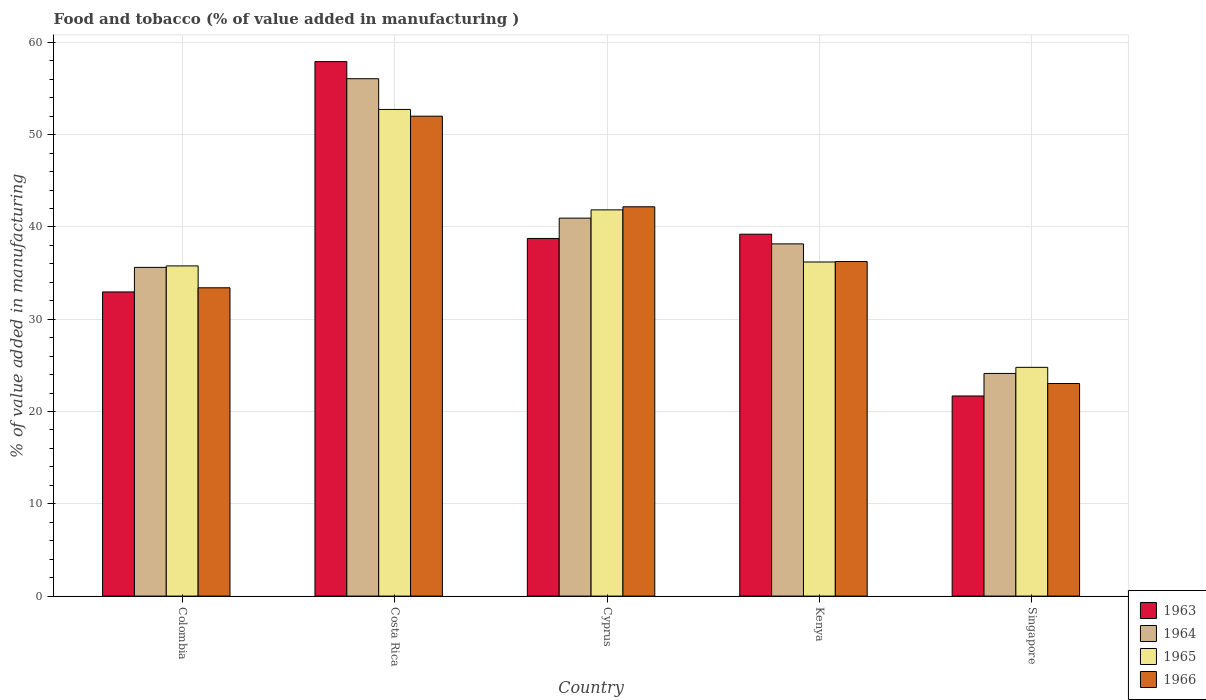How many groups of bars are there?
Offer a terse response. 5. Are the number of bars per tick equal to the number of legend labels?
Make the answer very short. Yes. How many bars are there on the 3rd tick from the left?
Give a very brief answer. 4. How many bars are there on the 1st tick from the right?
Provide a short and direct response. 4. What is the label of the 3rd group of bars from the left?
Keep it short and to the point. Cyprus. In how many cases, is the number of bars for a given country not equal to the number of legend labels?
Ensure brevity in your answer.  0. What is the value added in manufacturing food and tobacco in 1963 in Costa Rica?
Your answer should be very brief. 57.92. Across all countries, what is the maximum value added in manufacturing food and tobacco in 1965?
Ensure brevity in your answer.  52.73. Across all countries, what is the minimum value added in manufacturing food and tobacco in 1965?
Offer a terse response. 24.79. In which country was the value added in manufacturing food and tobacco in 1964 minimum?
Make the answer very short. Singapore. What is the total value added in manufacturing food and tobacco in 1965 in the graph?
Provide a short and direct response. 191.36. What is the difference between the value added in manufacturing food and tobacco in 1963 in Colombia and that in Cyprus?
Offer a very short reply. -5.79. What is the difference between the value added in manufacturing food and tobacco in 1966 in Singapore and the value added in manufacturing food and tobacco in 1963 in Costa Rica?
Your answer should be compact. -34.88. What is the average value added in manufacturing food and tobacco in 1965 per country?
Provide a short and direct response. 38.27. What is the difference between the value added in manufacturing food and tobacco of/in 1965 and value added in manufacturing food and tobacco of/in 1963 in Singapore?
Give a very brief answer. 3.1. In how many countries, is the value added in manufacturing food and tobacco in 1964 greater than 46 %?
Offer a very short reply. 1. What is the ratio of the value added in manufacturing food and tobacco in 1965 in Costa Rica to that in Singapore?
Give a very brief answer. 2.13. Is the value added in manufacturing food and tobacco in 1966 in Costa Rica less than that in Cyprus?
Your answer should be compact. No. What is the difference between the highest and the second highest value added in manufacturing food and tobacco in 1964?
Ensure brevity in your answer.  15.11. What is the difference between the highest and the lowest value added in manufacturing food and tobacco in 1964?
Offer a very short reply. 31.94. Is it the case that in every country, the sum of the value added in manufacturing food and tobacco in 1963 and value added in manufacturing food and tobacco in 1964 is greater than the sum of value added in manufacturing food and tobacco in 1966 and value added in manufacturing food and tobacco in 1965?
Your response must be concise. No. What does the 4th bar from the left in Cyprus represents?
Your response must be concise. 1966. What does the 2nd bar from the right in Colombia represents?
Offer a very short reply. 1965. How many bars are there?
Provide a succinct answer. 20. What is the difference between two consecutive major ticks on the Y-axis?
Keep it short and to the point. 10. How are the legend labels stacked?
Ensure brevity in your answer.  Vertical. What is the title of the graph?
Provide a succinct answer. Food and tobacco (% of value added in manufacturing ). What is the label or title of the Y-axis?
Your response must be concise. % of value added in manufacturing. What is the % of value added in manufacturing in 1963 in Colombia?
Offer a very short reply. 32.96. What is the % of value added in manufacturing of 1964 in Colombia?
Ensure brevity in your answer.  35.62. What is the % of value added in manufacturing of 1965 in Colombia?
Your response must be concise. 35.78. What is the % of value added in manufacturing of 1966 in Colombia?
Offer a very short reply. 33.41. What is the % of value added in manufacturing in 1963 in Costa Rica?
Provide a succinct answer. 57.92. What is the % of value added in manufacturing of 1964 in Costa Rica?
Your answer should be very brief. 56.07. What is the % of value added in manufacturing in 1965 in Costa Rica?
Your answer should be compact. 52.73. What is the % of value added in manufacturing of 1966 in Costa Rica?
Provide a succinct answer. 52. What is the % of value added in manufacturing in 1963 in Cyprus?
Your answer should be very brief. 38.75. What is the % of value added in manufacturing in 1964 in Cyprus?
Ensure brevity in your answer.  40.96. What is the % of value added in manufacturing of 1965 in Cyprus?
Provide a short and direct response. 41.85. What is the % of value added in manufacturing in 1966 in Cyprus?
Provide a short and direct response. 42.19. What is the % of value added in manufacturing in 1963 in Kenya?
Ensure brevity in your answer.  39.22. What is the % of value added in manufacturing in 1964 in Kenya?
Make the answer very short. 38.17. What is the % of value added in manufacturing of 1965 in Kenya?
Ensure brevity in your answer.  36.2. What is the % of value added in manufacturing of 1966 in Kenya?
Offer a terse response. 36.25. What is the % of value added in manufacturing in 1963 in Singapore?
Keep it short and to the point. 21.69. What is the % of value added in manufacturing of 1964 in Singapore?
Your response must be concise. 24.13. What is the % of value added in manufacturing in 1965 in Singapore?
Your answer should be compact. 24.79. What is the % of value added in manufacturing of 1966 in Singapore?
Your answer should be very brief. 23.04. Across all countries, what is the maximum % of value added in manufacturing of 1963?
Your answer should be compact. 57.92. Across all countries, what is the maximum % of value added in manufacturing of 1964?
Offer a terse response. 56.07. Across all countries, what is the maximum % of value added in manufacturing of 1965?
Offer a very short reply. 52.73. Across all countries, what is the maximum % of value added in manufacturing in 1966?
Keep it short and to the point. 52. Across all countries, what is the minimum % of value added in manufacturing of 1963?
Your response must be concise. 21.69. Across all countries, what is the minimum % of value added in manufacturing in 1964?
Offer a very short reply. 24.13. Across all countries, what is the minimum % of value added in manufacturing of 1965?
Provide a short and direct response. 24.79. Across all countries, what is the minimum % of value added in manufacturing in 1966?
Your response must be concise. 23.04. What is the total % of value added in manufacturing of 1963 in the graph?
Your answer should be compact. 190.54. What is the total % of value added in manufacturing of 1964 in the graph?
Your answer should be very brief. 194.94. What is the total % of value added in manufacturing of 1965 in the graph?
Offer a terse response. 191.36. What is the total % of value added in manufacturing of 1966 in the graph?
Give a very brief answer. 186.89. What is the difference between the % of value added in manufacturing of 1963 in Colombia and that in Costa Rica?
Your answer should be compact. -24.96. What is the difference between the % of value added in manufacturing in 1964 in Colombia and that in Costa Rica?
Ensure brevity in your answer.  -20.45. What is the difference between the % of value added in manufacturing in 1965 in Colombia and that in Costa Rica?
Make the answer very short. -16.95. What is the difference between the % of value added in manufacturing in 1966 in Colombia and that in Costa Rica?
Make the answer very short. -18.59. What is the difference between the % of value added in manufacturing in 1963 in Colombia and that in Cyprus?
Your answer should be compact. -5.79. What is the difference between the % of value added in manufacturing in 1964 in Colombia and that in Cyprus?
Your answer should be very brief. -5.34. What is the difference between the % of value added in manufacturing of 1965 in Colombia and that in Cyprus?
Provide a short and direct response. -6.07. What is the difference between the % of value added in manufacturing of 1966 in Colombia and that in Cyprus?
Your response must be concise. -8.78. What is the difference between the % of value added in manufacturing of 1963 in Colombia and that in Kenya?
Make the answer very short. -6.26. What is the difference between the % of value added in manufacturing of 1964 in Colombia and that in Kenya?
Your answer should be very brief. -2.55. What is the difference between the % of value added in manufacturing of 1965 in Colombia and that in Kenya?
Your answer should be very brief. -0.42. What is the difference between the % of value added in manufacturing of 1966 in Colombia and that in Kenya?
Your answer should be very brief. -2.84. What is the difference between the % of value added in manufacturing of 1963 in Colombia and that in Singapore?
Your response must be concise. 11.27. What is the difference between the % of value added in manufacturing in 1964 in Colombia and that in Singapore?
Provide a succinct answer. 11.49. What is the difference between the % of value added in manufacturing in 1965 in Colombia and that in Singapore?
Ensure brevity in your answer.  10.99. What is the difference between the % of value added in manufacturing of 1966 in Colombia and that in Singapore?
Offer a very short reply. 10.37. What is the difference between the % of value added in manufacturing in 1963 in Costa Rica and that in Cyprus?
Keep it short and to the point. 19.17. What is the difference between the % of value added in manufacturing in 1964 in Costa Rica and that in Cyprus?
Your answer should be very brief. 15.11. What is the difference between the % of value added in manufacturing of 1965 in Costa Rica and that in Cyprus?
Provide a succinct answer. 10.88. What is the difference between the % of value added in manufacturing in 1966 in Costa Rica and that in Cyprus?
Your answer should be very brief. 9.82. What is the difference between the % of value added in manufacturing in 1963 in Costa Rica and that in Kenya?
Offer a terse response. 18.7. What is the difference between the % of value added in manufacturing in 1964 in Costa Rica and that in Kenya?
Ensure brevity in your answer.  17.9. What is the difference between the % of value added in manufacturing of 1965 in Costa Rica and that in Kenya?
Offer a very short reply. 16.53. What is the difference between the % of value added in manufacturing of 1966 in Costa Rica and that in Kenya?
Offer a terse response. 15.75. What is the difference between the % of value added in manufacturing in 1963 in Costa Rica and that in Singapore?
Provide a short and direct response. 36.23. What is the difference between the % of value added in manufacturing of 1964 in Costa Rica and that in Singapore?
Your answer should be very brief. 31.94. What is the difference between the % of value added in manufacturing in 1965 in Costa Rica and that in Singapore?
Your answer should be very brief. 27.94. What is the difference between the % of value added in manufacturing of 1966 in Costa Rica and that in Singapore?
Your answer should be very brief. 28.97. What is the difference between the % of value added in manufacturing in 1963 in Cyprus and that in Kenya?
Provide a succinct answer. -0.46. What is the difference between the % of value added in manufacturing in 1964 in Cyprus and that in Kenya?
Provide a short and direct response. 2.79. What is the difference between the % of value added in manufacturing of 1965 in Cyprus and that in Kenya?
Offer a very short reply. 5.65. What is the difference between the % of value added in manufacturing in 1966 in Cyprus and that in Kenya?
Offer a very short reply. 5.93. What is the difference between the % of value added in manufacturing in 1963 in Cyprus and that in Singapore?
Your answer should be compact. 17.07. What is the difference between the % of value added in manufacturing in 1964 in Cyprus and that in Singapore?
Keep it short and to the point. 16.83. What is the difference between the % of value added in manufacturing in 1965 in Cyprus and that in Singapore?
Your answer should be very brief. 17.06. What is the difference between the % of value added in manufacturing in 1966 in Cyprus and that in Singapore?
Offer a terse response. 19.15. What is the difference between the % of value added in manufacturing in 1963 in Kenya and that in Singapore?
Offer a terse response. 17.53. What is the difference between the % of value added in manufacturing of 1964 in Kenya and that in Singapore?
Make the answer very short. 14.04. What is the difference between the % of value added in manufacturing of 1965 in Kenya and that in Singapore?
Provide a short and direct response. 11.41. What is the difference between the % of value added in manufacturing of 1966 in Kenya and that in Singapore?
Give a very brief answer. 13.22. What is the difference between the % of value added in manufacturing in 1963 in Colombia and the % of value added in manufacturing in 1964 in Costa Rica?
Provide a short and direct response. -23.11. What is the difference between the % of value added in manufacturing of 1963 in Colombia and the % of value added in manufacturing of 1965 in Costa Rica?
Your answer should be very brief. -19.77. What is the difference between the % of value added in manufacturing of 1963 in Colombia and the % of value added in manufacturing of 1966 in Costa Rica?
Make the answer very short. -19.04. What is the difference between the % of value added in manufacturing of 1964 in Colombia and the % of value added in manufacturing of 1965 in Costa Rica?
Offer a very short reply. -17.11. What is the difference between the % of value added in manufacturing of 1964 in Colombia and the % of value added in manufacturing of 1966 in Costa Rica?
Provide a succinct answer. -16.38. What is the difference between the % of value added in manufacturing in 1965 in Colombia and the % of value added in manufacturing in 1966 in Costa Rica?
Ensure brevity in your answer.  -16.22. What is the difference between the % of value added in manufacturing in 1963 in Colombia and the % of value added in manufacturing in 1964 in Cyprus?
Ensure brevity in your answer.  -8. What is the difference between the % of value added in manufacturing of 1963 in Colombia and the % of value added in manufacturing of 1965 in Cyprus?
Your response must be concise. -8.89. What is the difference between the % of value added in manufacturing of 1963 in Colombia and the % of value added in manufacturing of 1966 in Cyprus?
Make the answer very short. -9.23. What is the difference between the % of value added in manufacturing of 1964 in Colombia and the % of value added in manufacturing of 1965 in Cyprus?
Offer a very short reply. -6.23. What is the difference between the % of value added in manufacturing in 1964 in Colombia and the % of value added in manufacturing in 1966 in Cyprus?
Keep it short and to the point. -6.57. What is the difference between the % of value added in manufacturing of 1965 in Colombia and the % of value added in manufacturing of 1966 in Cyprus?
Your answer should be very brief. -6.41. What is the difference between the % of value added in manufacturing of 1963 in Colombia and the % of value added in manufacturing of 1964 in Kenya?
Your answer should be very brief. -5.21. What is the difference between the % of value added in manufacturing of 1963 in Colombia and the % of value added in manufacturing of 1965 in Kenya?
Provide a short and direct response. -3.24. What is the difference between the % of value added in manufacturing of 1963 in Colombia and the % of value added in manufacturing of 1966 in Kenya?
Provide a short and direct response. -3.29. What is the difference between the % of value added in manufacturing in 1964 in Colombia and the % of value added in manufacturing in 1965 in Kenya?
Keep it short and to the point. -0.58. What is the difference between the % of value added in manufacturing in 1964 in Colombia and the % of value added in manufacturing in 1966 in Kenya?
Make the answer very short. -0.63. What is the difference between the % of value added in manufacturing in 1965 in Colombia and the % of value added in manufacturing in 1966 in Kenya?
Give a very brief answer. -0.47. What is the difference between the % of value added in manufacturing in 1963 in Colombia and the % of value added in manufacturing in 1964 in Singapore?
Your answer should be very brief. 8.83. What is the difference between the % of value added in manufacturing of 1963 in Colombia and the % of value added in manufacturing of 1965 in Singapore?
Provide a short and direct response. 8.17. What is the difference between the % of value added in manufacturing in 1963 in Colombia and the % of value added in manufacturing in 1966 in Singapore?
Give a very brief answer. 9.92. What is the difference between the % of value added in manufacturing of 1964 in Colombia and the % of value added in manufacturing of 1965 in Singapore?
Provide a short and direct response. 10.83. What is the difference between the % of value added in manufacturing in 1964 in Colombia and the % of value added in manufacturing in 1966 in Singapore?
Make the answer very short. 12.58. What is the difference between the % of value added in manufacturing of 1965 in Colombia and the % of value added in manufacturing of 1966 in Singapore?
Your answer should be compact. 12.74. What is the difference between the % of value added in manufacturing of 1963 in Costa Rica and the % of value added in manufacturing of 1964 in Cyprus?
Ensure brevity in your answer.  16.96. What is the difference between the % of value added in manufacturing in 1963 in Costa Rica and the % of value added in manufacturing in 1965 in Cyprus?
Offer a very short reply. 16.07. What is the difference between the % of value added in manufacturing in 1963 in Costa Rica and the % of value added in manufacturing in 1966 in Cyprus?
Your response must be concise. 15.73. What is the difference between the % of value added in manufacturing in 1964 in Costa Rica and the % of value added in manufacturing in 1965 in Cyprus?
Offer a very short reply. 14.21. What is the difference between the % of value added in manufacturing of 1964 in Costa Rica and the % of value added in manufacturing of 1966 in Cyprus?
Make the answer very short. 13.88. What is the difference between the % of value added in manufacturing in 1965 in Costa Rica and the % of value added in manufacturing in 1966 in Cyprus?
Make the answer very short. 10.55. What is the difference between the % of value added in manufacturing in 1963 in Costa Rica and the % of value added in manufacturing in 1964 in Kenya?
Give a very brief answer. 19.75. What is the difference between the % of value added in manufacturing of 1963 in Costa Rica and the % of value added in manufacturing of 1965 in Kenya?
Your response must be concise. 21.72. What is the difference between the % of value added in manufacturing in 1963 in Costa Rica and the % of value added in manufacturing in 1966 in Kenya?
Your response must be concise. 21.67. What is the difference between the % of value added in manufacturing in 1964 in Costa Rica and the % of value added in manufacturing in 1965 in Kenya?
Make the answer very short. 19.86. What is the difference between the % of value added in manufacturing in 1964 in Costa Rica and the % of value added in manufacturing in 1966 in Kenya?
Provide a short and direct response. 19.81. What is the difference between the % of value added in manufacturing of 1965 in Costa Rica and the % of value added in manufacturing of 1966 in Kenya?
Keep it short and to the point. 16.48. What is the difference between the % of value added in manufacturing in 1963 in Costa Rica and the % of value added in manufacturing in 1964 in Singapore?
Provide a short and direct response. 33.79. What is the difference between the % of value added in manufacturing in 1963 in Costa Rica and the % of value added in manufacturing in 1965 in Singapore?
Offer a very short reply. 33.13. What is the difference between the % of value added in manufacturing of 1963 in Costa Rica and the % of value added in manufacturing of 1966 in Singapore?
Your answer should be very brief. 34.88. What is the difference between the % of value added in manufacturing of 1964 in Costa Rica and the % of value added in manufacturing of 1965 in Singapore?
Your answer should be very brief. 31.28. What is the difference between the % of value added in manufacturing of 1964 in Costa Rica and the % of value added in manufacturing of 1966 in Singapore?
Make the answer very short. 33.03. What is the difference between the % of value added in manufacturing in 1965 in Costa Rica and the % of value added in manufacturing in 1966 in Singapore?
Your answer should be compact. 29.7. What is the difference between the % of value added in manufacturing of 1963 in Cyprus and the % of value added in manufacturing of 1964 in Kenya?
Provide a short and direct response. 0.59. What is the difference between the % of value added in manufacturing in 1963 in Cyprus and the % of value added in manufacturing in 1965 in Kenya?
Ensure brevity in your answer.  2.55. What is the difference between the % of value added in manufacturing in 1963 in Cyprus and the % of value added in manufacturing in 1966 in Kenya?
Keep it short and to the point. 2.5. What is the difference between the % of value added in manufacturing of 1964 in Cyprus and the % of value added in manufacturing of 1965 in Kenya?
Your response must be concise. 4.75. What is the difference between the % of value added in manufacturing of 1964 in Cyprus and the % of value added in manufacturing of 1966 in Kenya?
Make the answer very short. 4.7. What is the difference between the % of value added in manufacturing of 1965 in Cyprus and the % of value added in manufacturing of 1966 in Kenya?
Your response must be concise. 5.6. What is the difference between the % of value added in manufacturing of 1963 in Cyprus and the % of value added in manufacturing of 1964 in Singapore?
Your response must be concise. 14.63. What is the difference between the % of value added in manufacturing in 1963 in Cyprus and the % of value added in manufacturing in 1965 in Singapore?
Your response must be concise. 13.96. What is the difference between the % of value added in manufacturing in 1963 in Cyprus and the % of value added in manufacturing in 1966 in Singapore?
Your response must be concise. 15.72. What is the difference between the % of value added in manufacturing of 1964 in Cyprus and the % of value added in manufacturing of 1965 in Singapore?
Keep it short and to the point. 16.17. What is the difference between the % of value added in manufacturing in 1964 in Cyprus and the % of value added in manufacturing in 1966 in Singapore?
Provide a short and direct response. 17.92. What is the difference between the % of value added in manufacturing of 1965 in Cyprus and the % of value added in manufacturing of 1966 in Singapore?
Your answer should be very brief. 18.82. What is the difference between the % of value added in manufacturing in 1963 in Kenya and the % of value added in manufacturing in 1964 in Singapore?
Your answer should be very brief. 15.09. What is the difference between the % of value added in manufacturing in 1963 in Kenya and the % of value added in manufacturing in 1965 in Singapore?
Ensure brevity in your answer.  14.43. What is the difference between the % of value added in manufacturing in 1963 in Kenya and the % of value added in manufacturing in 1966 in Singapore?
Give a very brief answer. 16.18. What is the difference between the % of value added in manufacturing in 1964 in Kenya and the % of value added in manufacturing in 1965 in Singapore?
Provide a succinct answer. 13.38. What is the difference between the % of value added in manufacturing of 1964 in Kenya and the % of value added in manufacturing of 1966 in Singapore?
Your answer should be compact. 15.13. What is the difference between the % of value added in manufacturing in 1965 in Kenya and the % of value added in manufacturing in 1966 in Singapore?
Provide a succinct answer. 13.17. What is the average % of value added in manufacturing in 1963 per country?
Your response must be concise. 38.11. What is the average % of value added in manufacturing in 1964 per country?
Your response must be concise. 38.99. What is the average % of value added in manufacturing in 1965 per country?
Provide a short and direct response. 38.27. What is the average % of value added in manufacturing in 1966 per country?
Ensure brevity in your answer.  37.38. What is the difference between the % of value added in manufacturing in 1963 and % of value added in manufacturing in 1964 in Colombia?
Offer a very short reply. -2.66. What is the difference between the % of value added in manufacturing in 1963 and % of value added in manufacturing in 1965 in Colombia?
Your answer should be compact. -2.82. What is the difference between the % of value added in manufacturing in 1963 and % of value added in manufacturing in 1966 in Colombia?
Your answer should be compact. -0.45. What is the difference between the % of value added in manufacturing of 1964 and % of value added in manufacturing of 1965 in Colombia?
Ensure brevity in your answer.  -0.16. What is the difference between the % of value added in manufacturing of 1964 and % of value added in manufacturing of 1966 in Colombia?
Provide a succinct answer. 2.21. What is the difference between the % of value added in manufacturing in 1965 and % of value added in manufacturing in 1966 in Colombia?
Offer a terse response. 2.37. What is the difference between the % of value added in manufacturing of 1963 and % of value added in manufacturing of 1964 in Costa Rica?
Provide a succinct answer. 1.85. What is the difference between the % of value added in manufacturing of 1963 and % of value added in manufacturing of 1965 in Costa Rica?
Provide a short and direct response. 5.19. What is the difference between the % of value added in manufacturing of 1963 and % of value added in manufacturing of 1966 in Costa Rica?
Offer a terse response. 5.92. What is the difference between the % of value added in manufacturing of 1964 and % of value added in manufacturing of 1965 in Costa Rica?
Your response must be concise. 3.33. What is the difference between the % of value added in manufacturing in 1964 and % of value added in manufacturing in 1966 in Costa Rica?
Keep it short and to the point. 4.06. What is the difference between the % of value added in manufacturing of 1965 and % of value added in manufacturing of 1966 in Costa Rica?
Provide a short and direct response. 0.73. What is the difference between the % of value added in manufacturing in 1963 and % of value added in manufacturing in 1964 in Cyprus?
Offer a very short reply. -2.2. What is the difference between the % of value added in manufacturing in 1963 and % of value added in manufacturing in 1965 in Cyprus?
Your response must be concise. -3.1. What is the difference between the % of value added in manufacturing of 1963 and % of value added in manufacturing of 1966 in Cyprus?
Your answer should be very brief. -3.43. What is the difference between the % of value added in manufacturing in 1964 and % of value added in manufacturing in 1965 in Cyprus?
Ensure brevity in your answer.  -0.9. What is the difference between the % of value added in manufacturing in 1964 and % of value added in manufacturing in 1966 in Cyprus?
Provide a short and direct response. -1.23. What is the difference between the % of value added in manufacturing in 1963 and % of value added in manufacturing in 1964 in Kenya?
Ensure brevity in your answer.  1.05. What is the difference between the % of value added in manufacturing of 1963 and % of value added in manufacturing of 1965 in Kenya?
Your answer should be very brief. 3.01. What is the difference between the % of value added in manufacturing of 1963 and % of value added in manufacturing of 1966 in Kenya?
Provide a succinct answer. 2.96. What is the difference between the % of value added in manufacturing of 1964 and % of value added in manufacturing of 1965 in Kenya?
Give a very brief answer. 1.96. What is the difference between the % of value added in manufacturing of 1964 and % of value added in manufacturing of 1966 in Kenya?
Offer a very short reply. 1.91. What is the difference between the % of value added in manufacturing of 1963 and % of value added in manufacturing of 1964 in Singapore?
Your answer should be very brief. -2.44. What is the difference between the % of value added in manufacturing of 1963 and % of value added in manufacturing of 1965 in Singapore?
Provide a short and direct response. -3.1. What is the difference between the % of value added in manufacturing in 1963 and % of value added in manufacturing in 1966 in Singapore?
Offer a terse response. -1.35. What is the difference between the % of value added in manufacturing in 1964 and % of value added in manufacturing in 1965 in Singapore?
Keep it short and to the point. -0.66. What is the difference between the % of value added in manufacturing of 1964 and % of value added in manufacturing of 1966 in Singapore?
Give a very brief answer. 1.09. What is the difference between the % of value added in manufacturing in 1965 and % of value added in manufacturing in 1966 in Singapore?
Keep it short and to the point. 1.75. What is the ratio of the % of value added in manufacturing of 1963 in Colombia to that in Costa Rica?
Offer a terse response. 0.57. What is the ratio of the % of value added in manufacturing of 1964 in Colombia to that in Costa Rica?
Offer a terse response. 0.64. What is the ratio of the % of value added in manufacturing in 1965 in Colombia to that in Costa Rica?
Give a very brief answer. 0.68. What is the ratio of the % of value added in manufacturing in 1966 in Colombia to that in Costa Rica?
Provide a succinct answer. 0.64. What is the ratio of the % of value added in manufacturing in 1963 in Colombia to that in Cyprus?
Give a very brief answer. 0.85. What is the ratio of the % of value added in manufacturing in 1964 in Colombia to that in Cyprus?
Provide a succinct answer. 0.87. What is the ratio of the % of value added in manufacturing of 1965 in Colombia to that in Cyprus?
Keep it short and to the point. 0.85. What is the ratio of the % of value added in manufacturing in 1966 in Colombia to that in Cyprus?
Keep it short and to the point. 0.79. What is the ratio of the % of value added in manufacturing in 1963 in Colombia to that in Kenya?
Provide a succinct answer. 0.84. What is the ratio of the % of value added in manufacturing of 1964 in Colombia to that in Kenya?
Give a very brief answer. 0.93. What is the ratio of the % of value added in manufacturing in 1965 in Colombia to that in Kenya?
Offer a very short reply. 0.99. What is the ratio of the % of value added in manufacturing of 1966 in Colombia to that in Kenya?
Your response must be concise. 0.92. What is the ratio of the % of value added in manufacturing in 1963 in Colombia to that in Singapore?
Offer a very short reply. 1.52. What is the ratio of the % of value added in manufacturing in 1964 in Colombia to that in Singapore?
Your answer should be compact. 1.48. What is the ratio of the % of value added in manufacturing of 1965 in Colombia to that in Singapore?
Give a very brief answer. 1.44. What is the ratio of the % of value added in manufacturing of 1966 in Colombia to that in Singapore?
Your answer should be compact. 1.45. What is the ratio of the % of value added in manufacturing in 1963 in Costa Rica to that in Cyprus?
Give a very brief answer. 1.49. What is the ratio of the % of value added in manufacturing of 1964 in Costa Rica to that in Cyprus?
Provide a succinct answer. 1.37. What is the ratio of the % of value added in manufacturing of 1965 in Costa Rica to that in Cyprus?
Give a very brief answer. 1.26. What is the ratio of the % of value added in manufacturing of 1966 in Costa Rica to that in Cyprus?
Your answer should be very brief. 1.23. What is the ratio of the % of value added in manufacturing in 1963 in Costa Rica to that in Kenya?
Give a very brief answer. 1.48. What is the ratio of the % of value added in manufacturing of 1964 in Costa Rica to that in Kenya?
Offer a very short reply. 1.47. What is the ratio of the % of value added in manufacturing in 1965 in Costa Rica to that in Kenya?
Offer a terse response. 1.46. What is the ratio of the % of value added in manufacturing of 1966 in Costa Rica to that in Kenya?
Your response must be concise. 1.43. What is the ratio of the % of value added in manufacturing in 1963 in Costa Rica to that in Singapore?
Your answer should be very brief. 2.67. What is the ratio of the % of value added in manufacturing in 1964 in Costa Rica to that in Singapore?
Ensure brevity in your answer.  2.32. What is the ratio of the % of value added in manufacturing in 1965 in Costa Rica to that in Singapore?
Offer a terse response. 2.13. What is the ratio of the % of value added in manufacturing of 1966 in Costa Rica to that in Singapore?
Your response must be concise. 2.26. What is the ratio of the % of value added in manufacturing in 1963 in Cyprus to that in Kenya?
Offer a terse response. 0.99. What is the ratio of the % of value added in manufacturing of 1964 in Cyprus to that in Kenya?
Offer a very short reply. 1.07. What is the ratio of the % of value added in manufacturing of 1965 in Cyprus to that in Kenya?
Keep it short and to the point. 1.16. What is the ratio of the % of value added in manufacturing in 1966 in Cyprus to that in Kenya?
Keep it short and to the point. 1.16. What is the ratio of the % of value added in manufacturing of 1963 in Cyprus to that in Singapore?
Give a very brief answer. 1.79. What is the ratio of the % of value added in manufacturing of 1964 in Cyprus to that in Singapore?
Make the answer very short. 1.7. What is the ratio of the % of value added in manufacturing in 1965 in Cyprus to that in Singapore?
Keep it short and to the point. 1.69. What is the ratio of the % of value added in manufacturing in 1966 in Cyprus to that in Singapore?
Provide a succinct answer. 1.83. What is the ratio of the % of value added in manufacturing in 1963 in Kenya to that in Singapore?
Ensure brevity in your answer.  1.81. What is the ratio of the % of value added in manufacturing in 1964 in Kenya to that in Singapore?
Give a very brief answer. 1.58. What is the ratio of the % of value added in manufacturing in 1965 in Kenya to that in Singapore?
Ensure brevity in your answer.  1.46. What is the ratio of the % of value added in manufacturing in 1966 in Kenya to that in Singapore?
Provide a short and direct response. 1.57. What is the difference between the highest and the second highest % of value added in manufacturing of 1963?
Your answer should be very brief. 18.7. What is the difference between the highest and the second highest % of value added in manufacturing in 1964?
Provide a short and direct response. 15.11. What is the difference between the highest and the second highest % of value added in manufacturing in 1965?
Provide a short and direct response. 10.88. What is the difference between the highest and the second highest % of value added in manufacturing of 1966?
Provide a short and direct response. 9.82. What is the difference between the highest and the lowest % of value added in manufacturing in 1963?
Your answer should be very brief. 36.23. What is the difference between the highest and the lowest % of value added in manufacturing of 1964?
Ensure brevity in your answer.  31.94. What is the difference between the highest and the lowest % of value added in manufacturing of 1965?
Your answer should be compact. 27.94. What is the difference between the highest and the lowest % of value added in manufacturing in 1966?
Offer a very short reply. 28.97. 